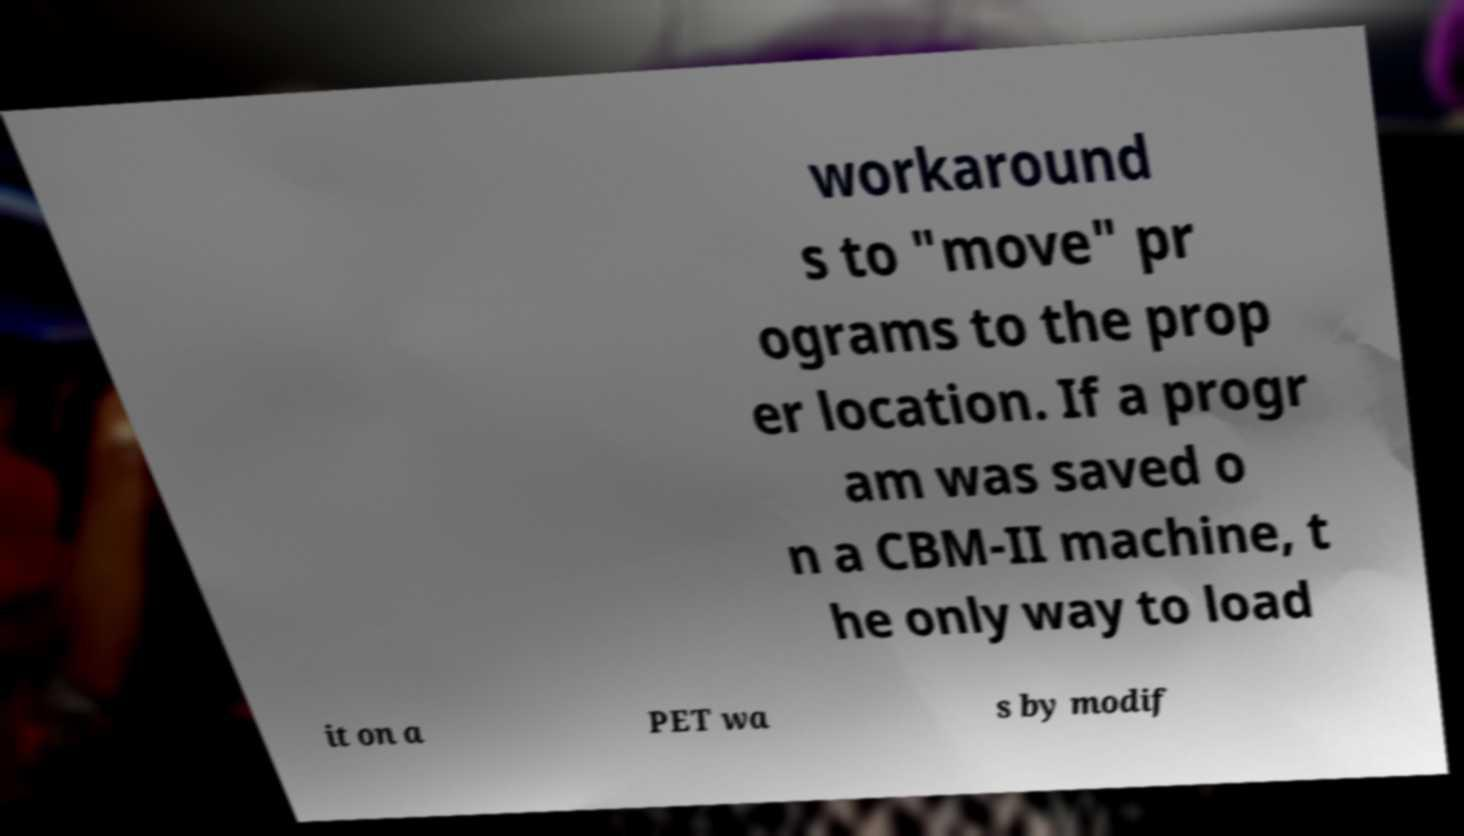Please read and relay the text visible in this image. What does it say? workaround s to "move" pr ograms to the prop er location. If a progr am was saved o n a CBM-II machine, t he only way to load it on a PET wa s by modif 